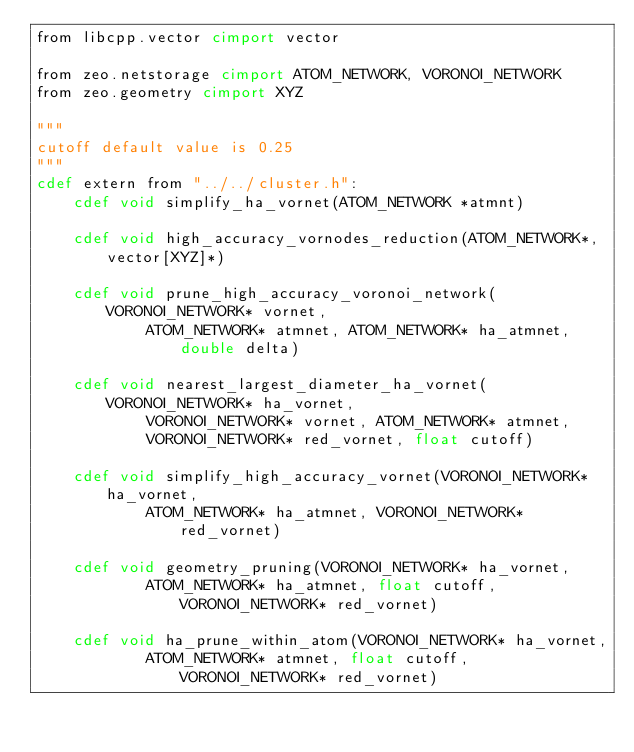Convert code to text. <code><loc_0><loc_0><loc_500><loc_500><_Cython_>from libcpp.vector cimport vector

from zeo.netstorage cimport ATOM_NETWORK, VORONOI_NETWORK
from zeo.geometry cimport XYZ

"""
cutoff default value is 0.25
"""
cdef extern from "../../cluster.h":
    cdef void simplify_ha_vornet(ATOM_NETWORK *atmnt)

    cdef void high_accuracy_vornodes_reduction(ATOM_NETWORK*, vector[XYZ]*)

    cdef void prune_high_accuracy_voronoi_network(VORONOI_NETWORK* vornet,
            ATOM_NETWORK* atmnet, ATOM_NETWORK* ha_atmnet, double delta)

    cdef void nearest_largest_diameter_ha_vornet(VORONOI_NETWORK* ha_vornet,
            VORONOI_NETWORK* vornet, ATOM_NETWORK* atmnet,
            VORONOI_NETWORK* red_vornet, float cutoff)

    cdef void simplify_high_accuracy_vornet(VORONOI_NETWORK* ha_vornet,
            ATOM_NETWORK* ha_atmnet, VORONOI_NETWORK* red_vornet)

    cdef void geometry_pruning(VORONOI_NETWORK* ha_vornet,
            ATOM_NETWORK* ha_atmnet, float cutoff, VORONOI_NETWORK* red_vornet)

    cdef void ha_prune_within_atom(VORONOI_NETWORK* ha_vornet,
            ATOM_NETWORK* atmnet, float cutoff, VORONOI_NETWORK* red_vornet)
</code> 